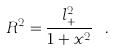<formula> <loc_0><loc_0><loc_500><loc_500>R ^ { 2 } = \frac { l _ { + } ^ { 2 } } { 1 + x ^ { 2 } } \ .</formula> 